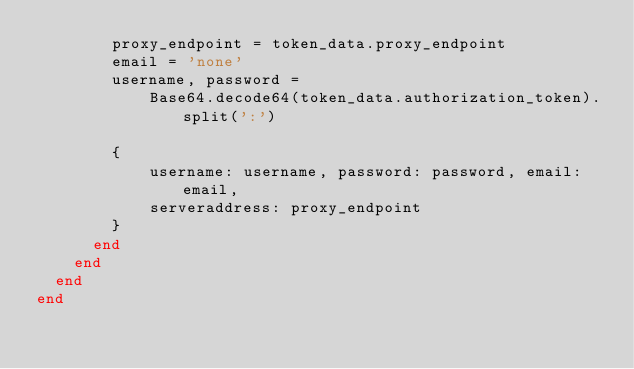Convert code to text. <code><loc_0><loc_0><loc_500><loc_500><_Ruby_>        proxy_endpoint = token_data.proxy_endpoint
        email = 'none'
        username, password =
            Base64.decode64(token_data.authorization_token).split(':')

        {
            username: username, password: password, email: email,
            serveraddress: proxy_endpoint
        }
      end
    end
  end
end</code> 